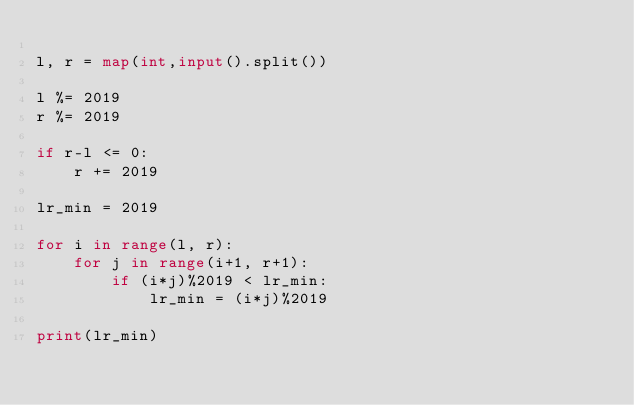Convert code to text. <code><loc_0><loc_0><loc_500><loc_500><_Python_>
l, r = map(int,input().split())

l %= 2019
r %= 2019

if r-l <= 0:
    r += 2019

lr_min = 2019

for i in range(l, r):
    for j in range(i+1, r+1):
        if (i*j)%2019 < lr_min:
            lr_min = (i*j)%2019

print(lr_min)
</code> 